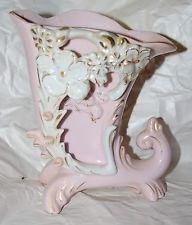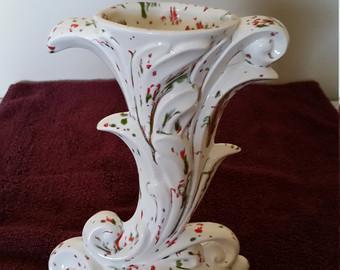The first image is the image on the left, the second image is the image on the right. For the images displayed, is the sentence "None of the vases contain flowers." factually correct? Answer yes or no. Yes. The first image is the image on the left, the second image is the image on the right. For the images displayed, is the sentence "None of the vases have flowers inserted into them." factually correct? Answer yes or no. Yes. 